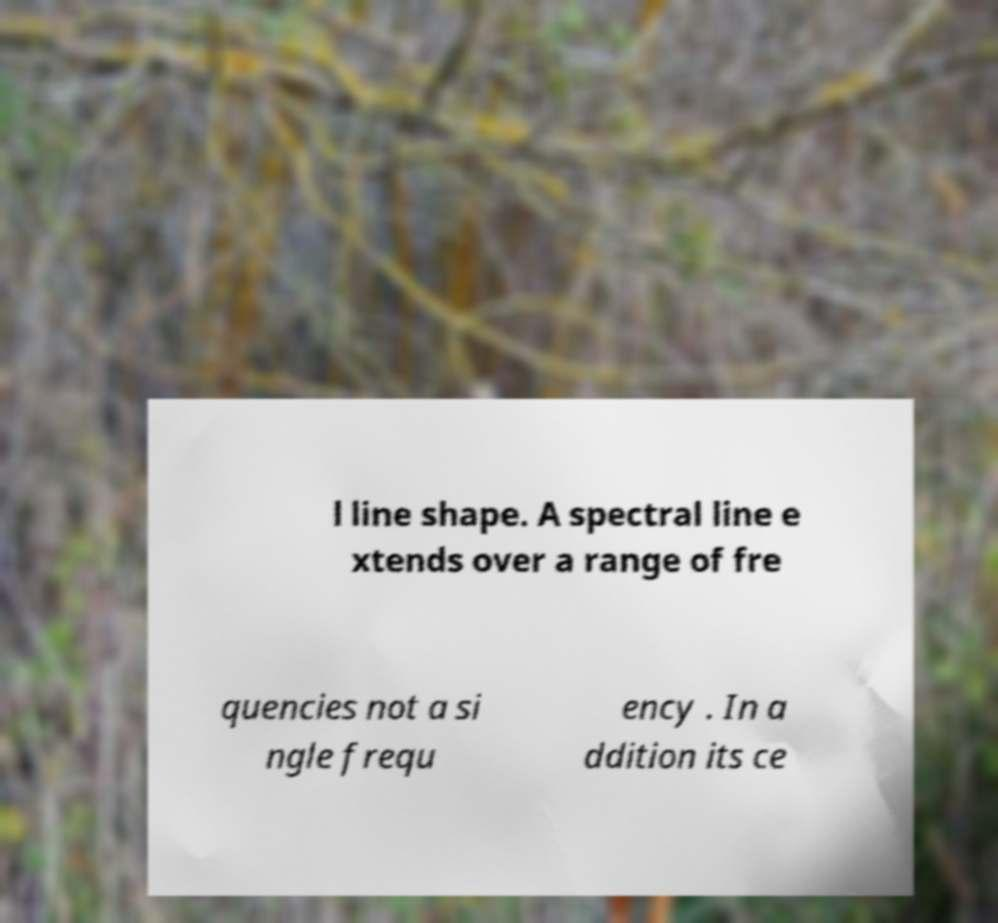Could you assist in decoding the text presented in this image and type it out clearly? l line shape. A spectral line e xtends over a range of fre quencies not a si ngle frequ ency . In a ddition its ce 